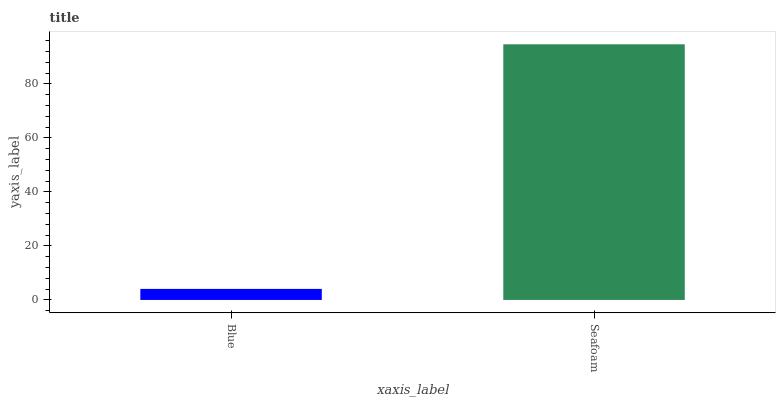Is Blue the minimum?
Answer yes or no. Yes. Is Seafoam the maximum?
Answer yes or no. Yes. Is Seafoam the minimum?
Answer yes or no. No. Is Seafoam greater than Blue?
Answer yes or no. Yes. Is Blue less than Seafoam?
Answer yes or no. Yes. Is Blue greater than Seafoam?
Answer yes or no. No. Is Seafoam less than Blue?
Answer yes or no. No. Is Seafoam the high median?
Answer yes or no. Yes. Is Blue the low median?
Answer yes or no. Yes. Is Blue the high median?
Answer yes or no. No. Is Seafoam the low median?
Answer yes or no. No. 